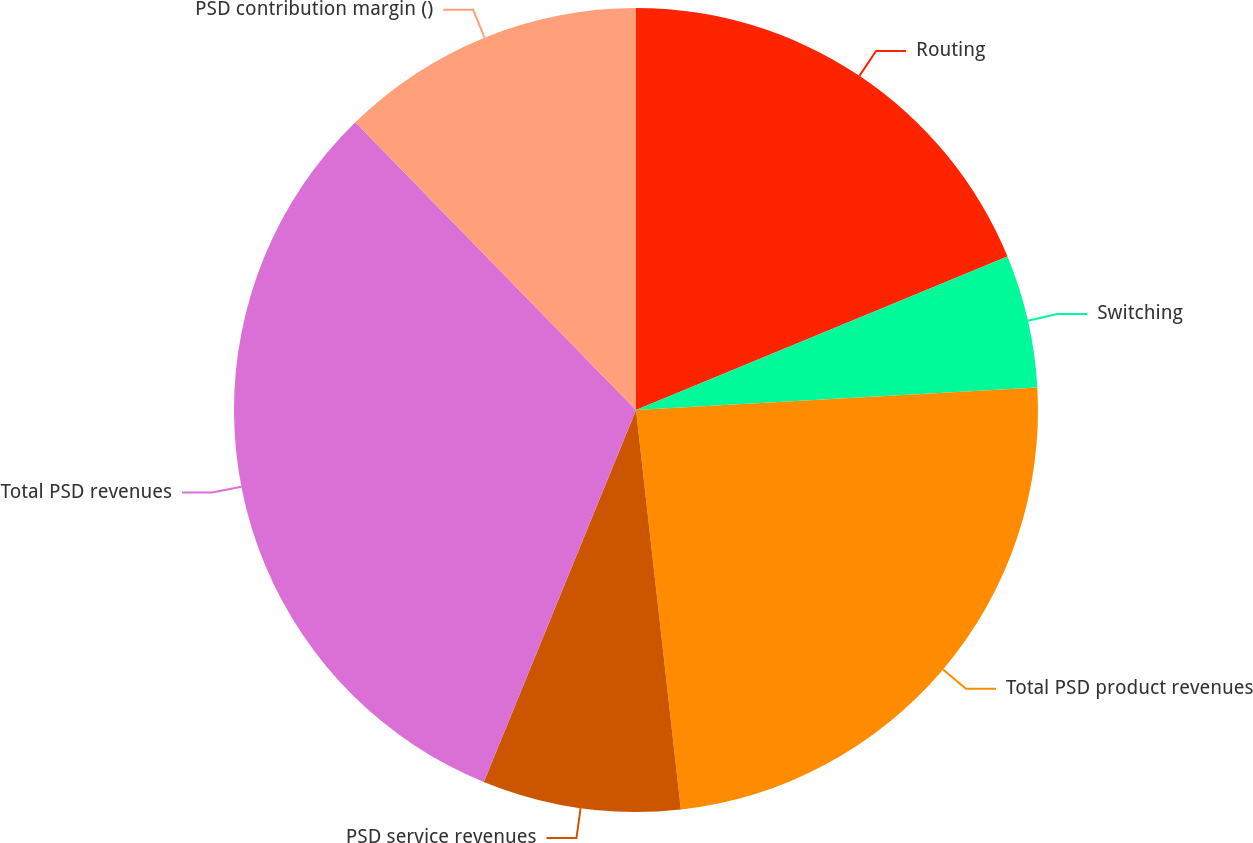Convert chart. <chart><loc_0><loc_0><loc_500><loc_500><pie_chart><fcel>Routing<fcel>Switching<fcel>Total PSD product revenues<fcel>PSD service revenues<fcel>Total PSD revenues<fcel>PSD contribution margin ()<nl><fcel>18.76%<fcel>5.35%<fcel>24.11%<fcel>7.96%<fcel>31.52%<fcel>12.3%<nl></chart> 